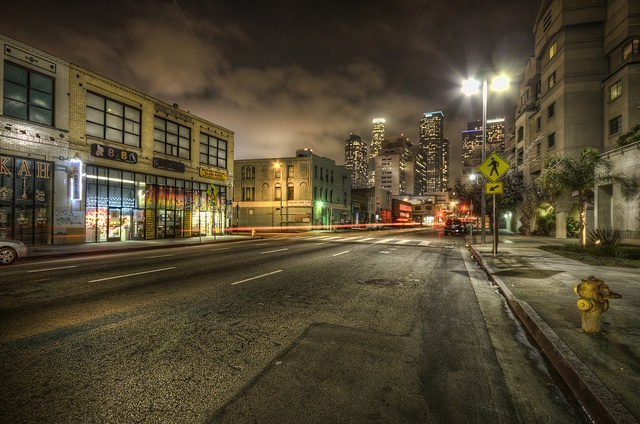Describe the objects in this image and their specific colors. I can see fire hydrant in black and olive tones, car in black, gray, and maroon tones, car in black, maroon, and gray tones, traffic light in black, ivory, khaki, and lightgreen tones, and traffic light in black, salmon, red, and yellow tones in this image. 